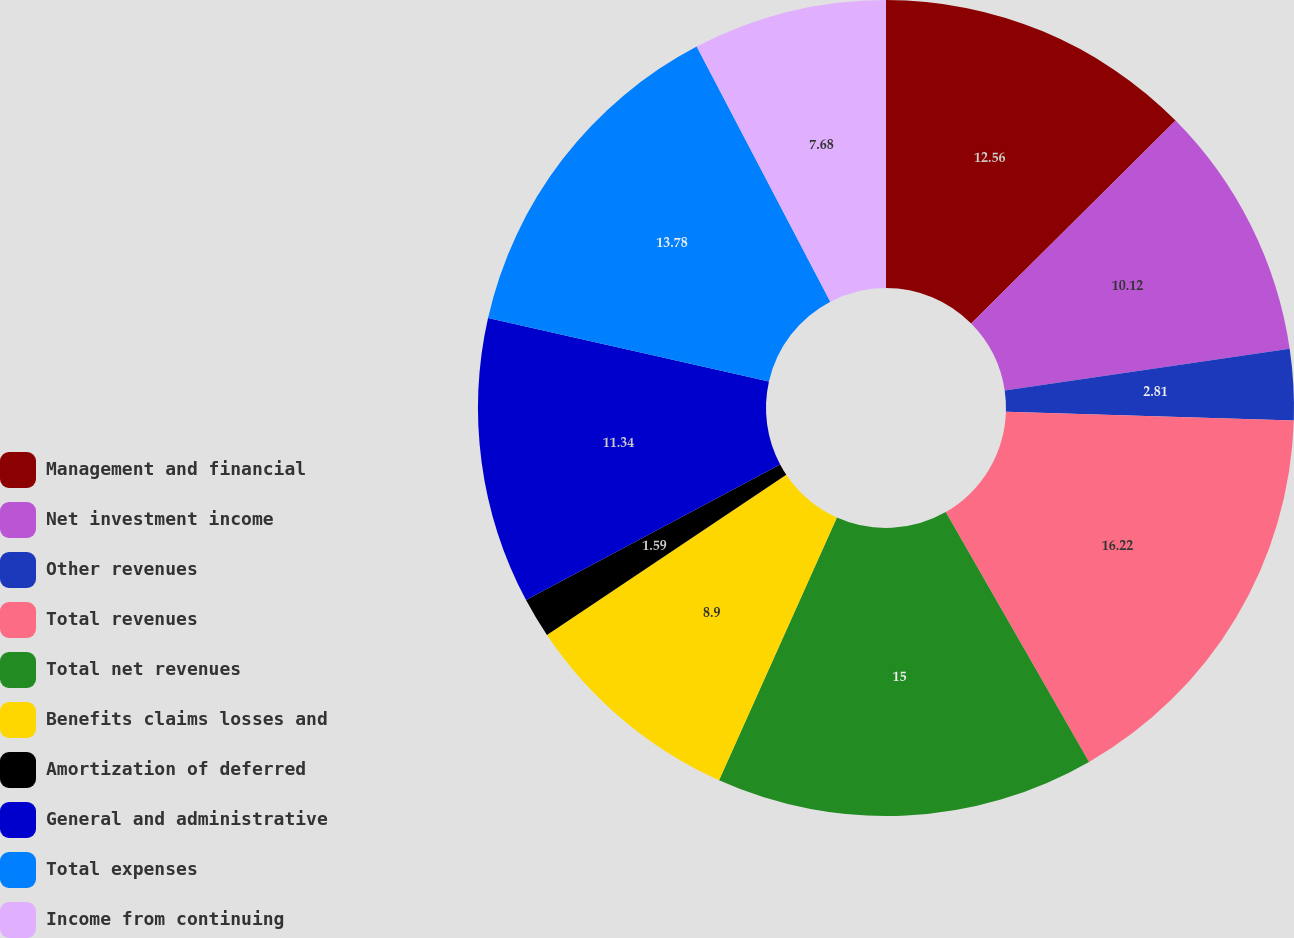Convert chart to OTSL. <chart><loc_0><loc_0><loc_500><loc_500><pie_chart><fcel>Management and financial<fcel>Net investment income<fcel>Other revenues<fcel>Total revenues<fcel>Total net revenues<fcel>Benefits claims losses and<fcel>Amortization of deferred<fcel>General and administrative<fcel>Total expenses<fcel>Income from continuing<nl><fcel>12.56%<fcel>10.12%<fcel>2.81%<fcel>16.22%<fcel>15.0%<fcel>8.9%<fcel>1.59%<fcel>11.34%<fcel>13.78%<fcel>7.68%<nl></chart> 